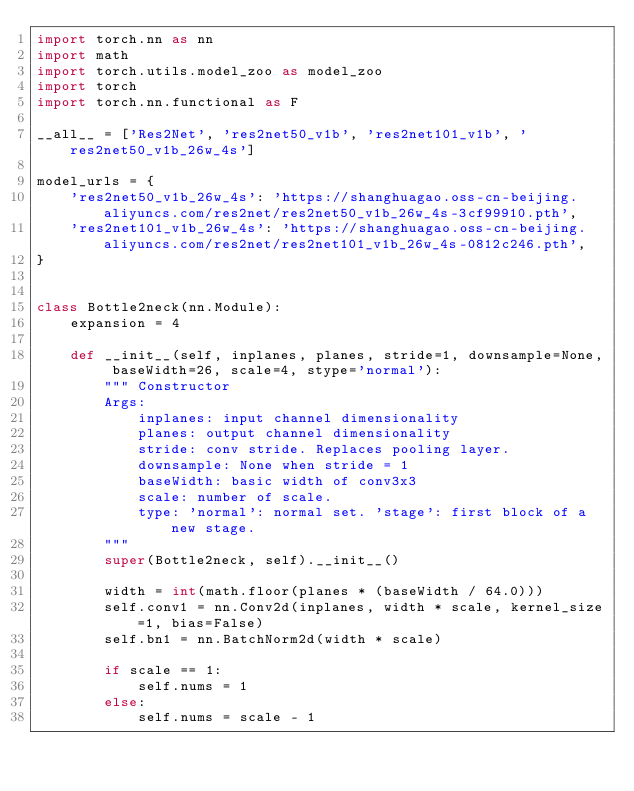Convert code to text. <code><loc_0><loc_0><loc_500><loc_500><_Python_>import torch.nn as nn
import math
import torch.utils.model_zoo as model_zoo
import torch
import torch.nn.functional as F

__all__ = ['Res2Net', 'res2net50_v1b', 'res2net101_v1b', 'res2net50_v1b_26w_4s']

model_urls = {
    'res2net50_v1b_26w_4s': 'https://shanghuagao.oss-cn-beijing.aliyuncs.com/res2net/res2net50_v1b_26w_4s-3cf99910.pth',
    'res2net101_v1b_26w_4s': 'https://shanghuagao.oss-cn-beijing.aliyuncs.com/res2net/res2net101_v1b_26w_4s-0812c246.pth',
}


class Bottle2neck(nn.Module):
    expansion = 4

    def __init__(self, inplanes, planes, stride=1, downsample=None, baseWidth=26, scale=4, stype='normal'):
        """ Constructor
        Args:
            inplanes: input channel dimensionality
            planes: output channel dimensionality
            stride: conv stride. Replaces pooling layer.
            downsample: None when stride = 1
            baseWidth: basic width of conv3x3
            scale: number of scale.
            type: 'normal': normal set. 'stage': first block of a new stage.
        """
        super(Bottle2neck, self).__init__()

        width = int(math.floor(planes * (baseWidth / 64.0)))
        self.conv1 = nn.Conv2d(inplanes, width * scale, kernel_size=1, bias=False)
        self.bn1 = nn.BatchNorm2d(width * scale)

        if scale == 1:
            self.nums = 1
        else:
            self.nums = scale - 1</code> 